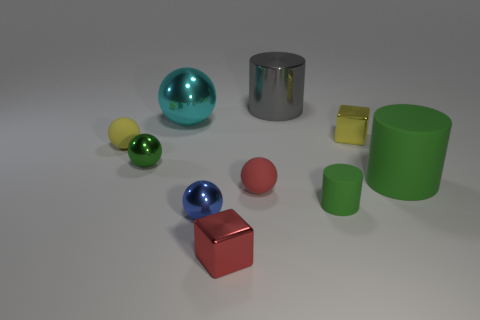What is the size of the other cylinder that is the same color as the tiny cylinder?
Offer a very short reply. Large. What is the size of the gray object that is the same material as the blue ball?
Give a very brief answer. Large. How big is the green rubber thing that is behind the red object to the right of the small red block?
Keep it short and to the point. Large. What number of other things are there of the same color as the big matte object?
Provide a succinct answer. 2. There is a large matte cylinder; is it the same color as the tiny metal ball behind the small cylinder?
Make the answer very short. Yes. There is a green rubber object that is on the right side of the small yellow block; how many tiny red matte objects are behind it?
Provide a succinct answer. 0. There is a small sphere on the right side of the small shiny ball in front of the big green thing; what is its color?
Provide a succinct answer. Red. There is a small thing that is both behind the green shiny thing and to the left of the blue metal ball; what material is it made of?
Make the answer very short. Rubber. Are there any red rubber things that have the same shape as the tiny blue object?
Make the answer very short. Yes. Is the shape of the tiny yellow thing that is right of the green metallic sphere the same as  the red metal thing?
Offer a very short reply. Yes. 